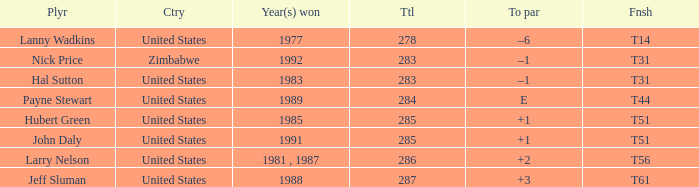What is Country, when Total is greater than 283, and when Year(s) Won is "1989"? United States. 